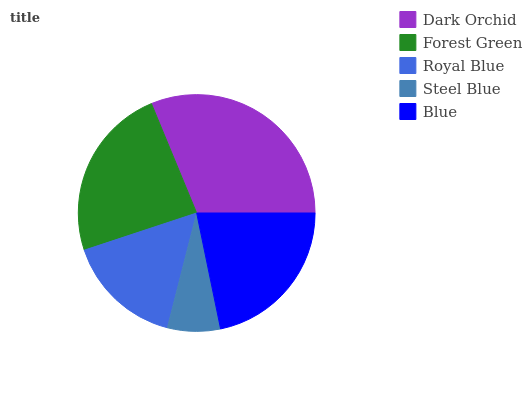Is Steel Blue the minimum?
Answer yes or no. Yes. Is Dark Orchid the maximum?
Answer yes or no. Yes. Is Forest Green the minimum?
Answer yes or no. No. Is Forest Green the maximum?
Answer yes or no. No. Is Dark Orchid greater than Forest Green?
Answer yes or no. Yes. Is Forest Green less than Dark Orchid?
Answer yes or no. Yes. Is Forest Green greater than Dark Orchid?
Answer yes or no. No. Is Dark Orchid less than Forest Green?
Answer yes or no. No. Is Blue the high median?
Answer yes or no. Yes. Is Blue the low median?
Answer yes or no. Yes. Is Forest Green the high median?
Answer yes or no. No. Is Dark Orchid the low median?
Answer yes or no. No. 